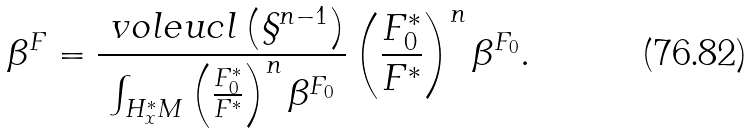<formula> <loc_0><loc_0><loc_500><loc_500>\beta ^ { F } = \frac { \ v o l e u c l \left ( \S ^ { n - 1 } \right ) } { \int _ { H _ { x } ^ { \ast } M } \left ( \frac { F _ { 0 } ^ { \ast } } { F ^ { \ast } } \right ) ^ { n } \beta ^ { F _ { 0 } } } \left ( \frac { F _ { 0 } ^ { \ast } } { F ^ { \ast } } \right ) ^ { n } \beta ^ { F _ { 0 } } .</formula> 